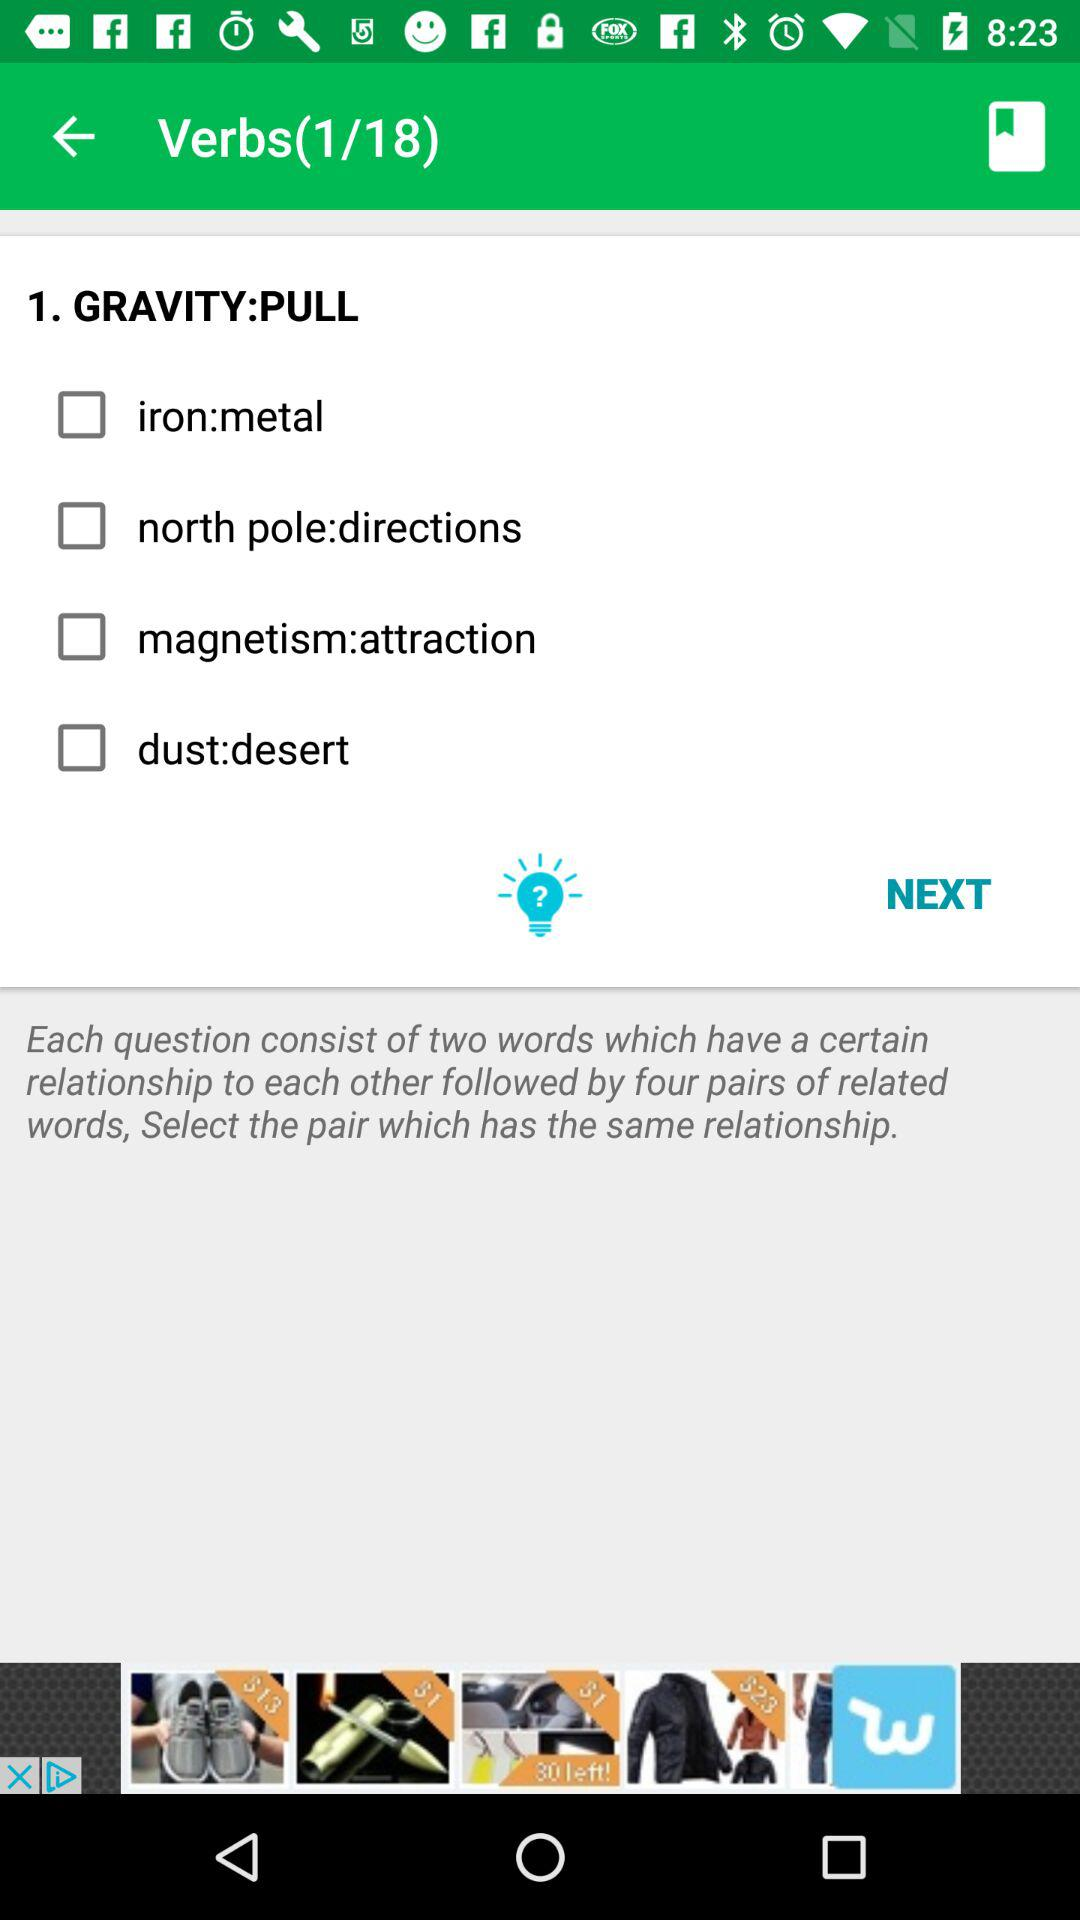How many verbs are there in total? There are 18 verbs in total. 